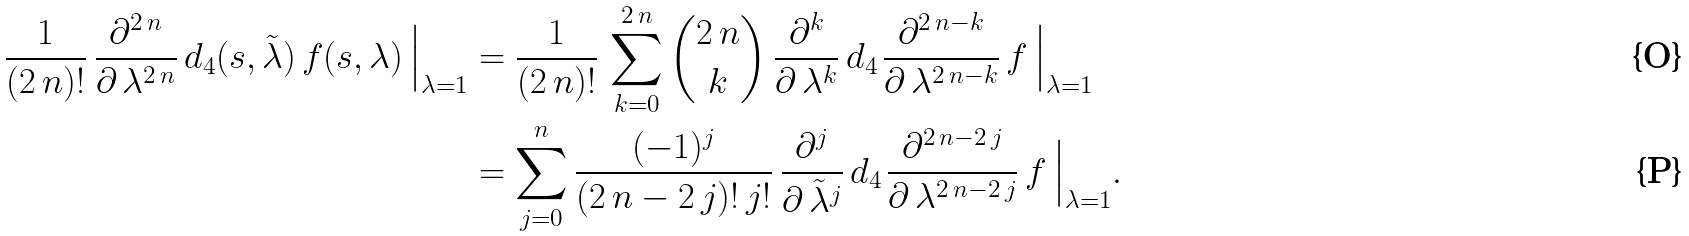Convert formula to latex. <formula><loc_0><loc_0><loc_500><loc_500>\frac { 1 } { ( 2 \, n ) ! } \, \frac { \partial ^ { 2 \, n } } { \partial \, \lambda ^ { 2 \, n } } \, d _ { 4 } ( s , \tilde { \lambda } ) \, f ( s , \lambda ) \, \Big { | } _ { \lambda = 1 } & = \frac { 1 } { ( 2 \, n ) ! } \, \sum _ { k = 0 } ^ { 2 \, n } \binom { 2 \, n } { k } \, \frac { \partial ^ { k } } { \partial \, \lambda ^ { k } } \, d _ { 4 \, } \frac { \partial ^ { 2 \, n - k } } { \partial \, \lambda ^ { 2 \, n - k } } \, f \, \Big { | } _ { \lambda = 1 } \\ & = \sum _ { j = 0 } ^ { n } \frac { ( - 1 ) ^ { j } } { ( 2 \, n - 2 \, j ) ! \, j ! } \, \frac { \partial ^ { j } } { \partial \, \tilde { \lambda } ^ { j } } \, d _ { 4 \, } \frac { \partial ^ { 2 \, n - 2 \, j } } { \partial \, \lambda ^ { 2 \, n - 2 \, j } } \, f \, \Big { | } _ { \lambda = 1 } .</formula> 